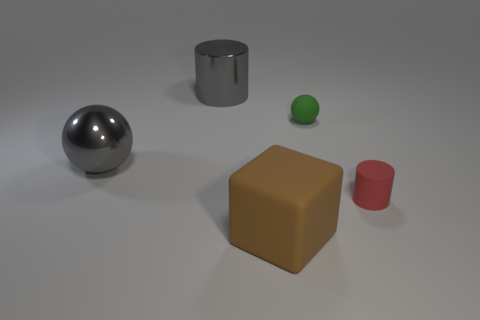How many large objects are either rubber things or gray shiny cylinders?
Your answer should be compact. 2. What number of things are behind the block and on the right side of the large gray shiny cylinder?
Offer a very short reply. 2. Is the number of tiny gray blocks greater than the number of big brown things?
Provide a short and direct response. No. How many other things are the same shape as the brown matte object?
Make the answer very short. 0. Is the rubber ball the same color as the rubber cube?
Keep it short and to the point. No. The big thing that is both right of the big sphere and in front of the tiny green ball is made of what material?
Your answer should be very brief. Rubber. What is the size of the brown rubber block?
Your response must be concise. Large. How many large gray shiny things are to the right of the gray shiny object that is to the left of the cylinder that is left of the small green object?
Provide a short and direct response. 1. The gray object to the right of the ball in front of the green rubber thing is what shape?
Ensure brevity in your answer.  Cylinder. What is the size of the gray thing that is the same shape as the tiny green matte object?
Give a very brief answer. Large. 